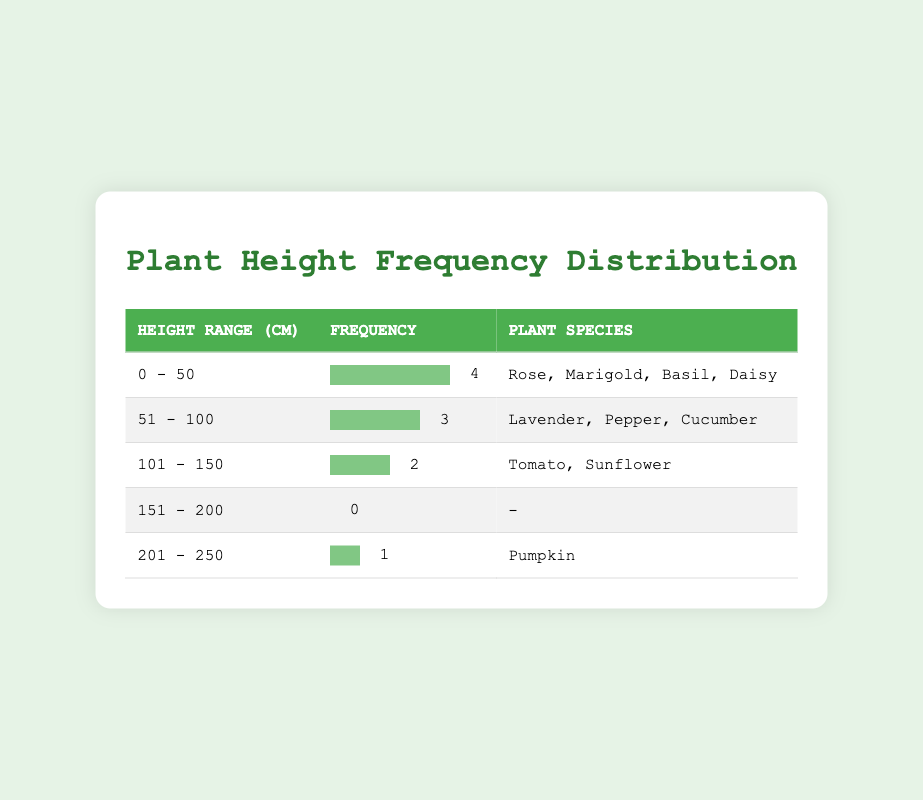What is the height range with the highest frequency of plant species? Looking at the frequency column, the height range with the highest frequency (4) is 0 - 50 cm. This row has the most occurrences of different plant species.
Answer: 0 - 50 cm How many plant species fall within the height range of 51 - 100 cm? The table shows that there are 3 plant species listed under the height range of 51 - 100 cm, which are Lavender, Pepper, and Cucumber.
Answer: 3 Is there any plant species that has a height of 250 cm? The table lists only one plant species at 250 cm, which is Pumpkin. Therefore, it is true that a plant species has this height.
Answer: Yes What is the total number of plant species represented in the frequency distribution? By counting the unique plant species listed in each height range, we find that there are 10 different plant species in total (Sunflower, Rose, Marigold, Basil, Tomato, Cucumber, Daisy, Lavender, Pepper, Pumpkin).
Answer: 10 What is the average height of plant species in the height range of 0 - 50 cm? The average can be calculated by taking the heights of the specified plant species (Rose = 30 cm, Marigold = 25 cm, Basil = 45 cm, Daisy = 20 cm), summing them up (30 + 25 + 45 + 20 = 120), and dividing by the number of species (120 / 4 = 30).
Answer: 30 cm 